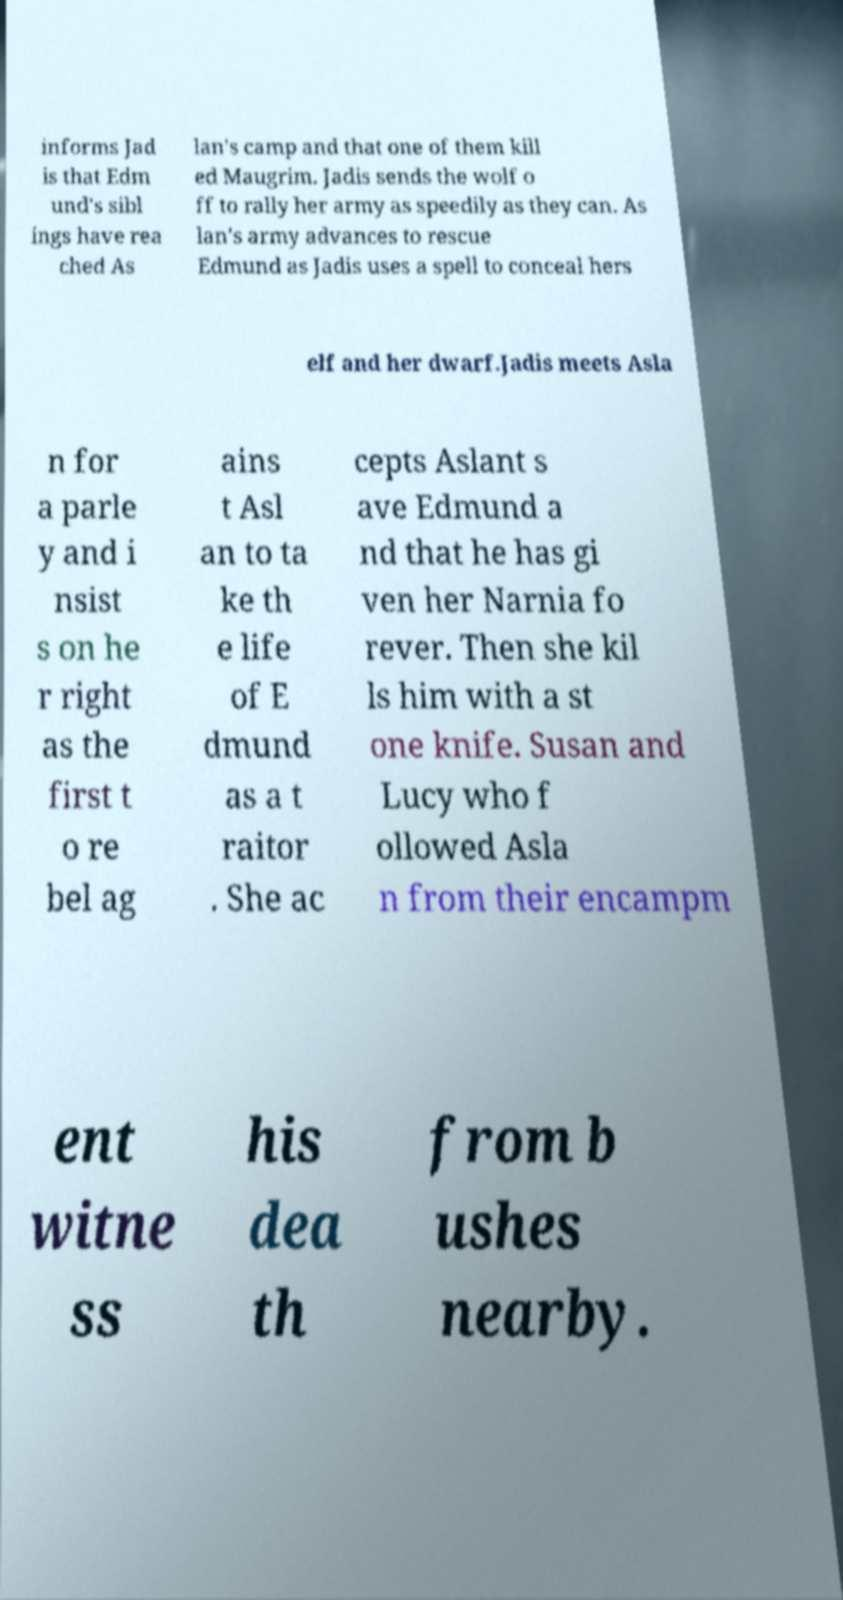I need the written content from this picture converted into text. Can you do that? informs Jad is that Edm und's sibl ings have rea ched As lan's camp and that one of them kill ed Maugrim. Jadis sends the wolf o ff to rally her army as speedily as they can. As lan's army advances to rescue Edmund as Jadis uses a spell to conceal hers elf and her dwarf.Jadis meets Asla n for a parle y and i nsist s on he r right as the first t o re bel ag ains t Asl an to ta ke th e life of E dmund as a t raitor . She ac cepts Aslant s ave Edmund a nd that he has gi ven her Narnia fo rever. Then she kil ls him with a st one knife. Susan and Lucy who f ollowed Asla n from their encampm ent witne ss his dea th from b ushes nearby. 